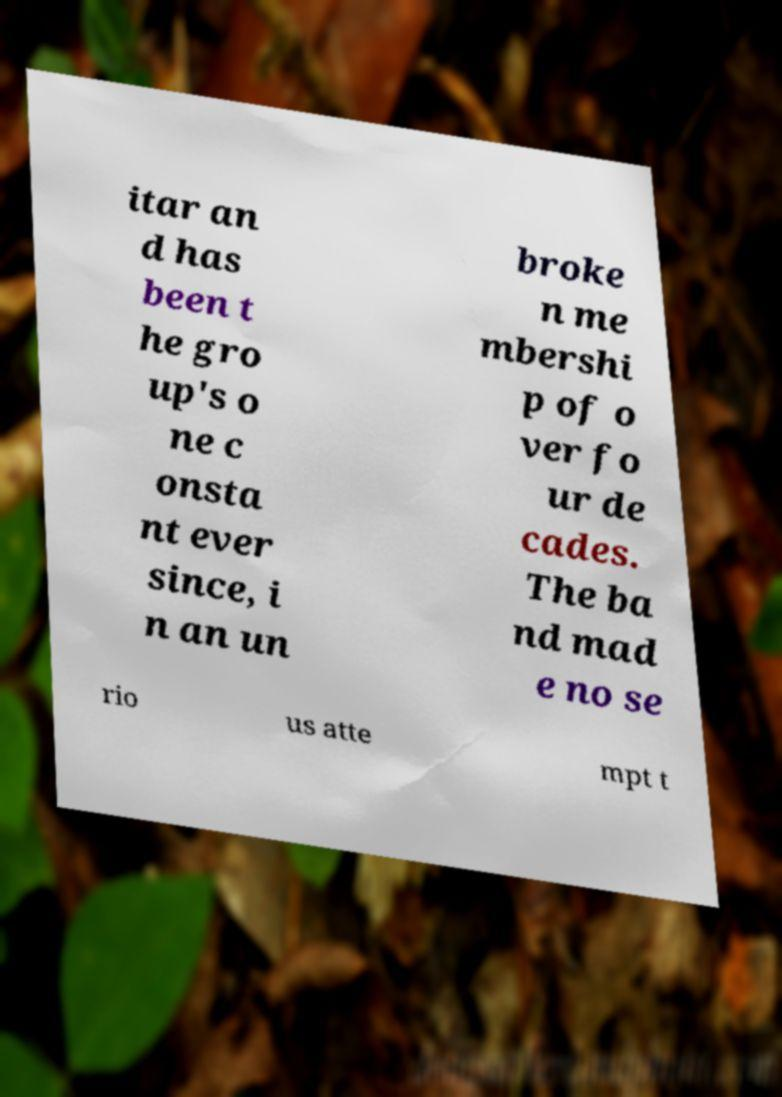Could you assist in decoding the text presented in this image and type it out clearly? itar an d has been t he gro up's o ne c onsta nt ever since, i n an un broke n me mbershi p of o ver fo ur de cades. The ba nd mad e no se rio us atte mpt t 